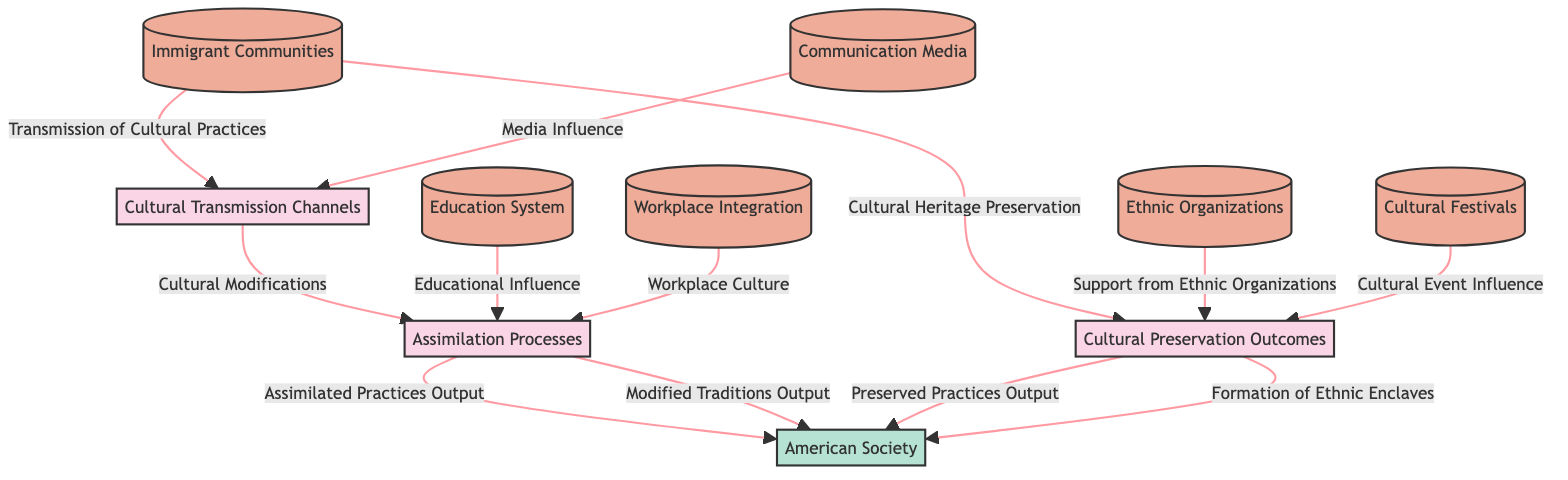What are the processes depicted in the diagram? The diagram lists three processes: Cultural Transmission Channels, Assimilation Processes, and Cultural Preservation Outcomes.
Answer: Cultural Transmission Channels, Assimilation Processes, Cultural Preservation Outcomes How many data stores are included in the diagram? There are six data stores identified in the diagram: Immigrant Communities, Communication Media, Education System, Workplace Integration, Ethnic Organizations, and Cultural Festivals.
Answer: Six What is the input for the Assimilation Processes? The inputs for Assimilation Processes are Cultural Influence in Society, Education System, and Workplace Integration.
Answer: Cultural Influence in Society, Education System, Workplace Integration What influences the Cultural Transmission Channels? Cultural Transmission Channels are influenced by Immigrant Communities and Communication Media.
Answer: Immigrant Communities, Communication Media Which process outputs Preserved Cultural Practices? The Cultural Preservation Outcomes process outputs Preserved Cultural Practices.
Answer: Cultural Preservation Outcomes What is the relationship between Cultural Transmission Channels and Assimilation Processes? Cultural Transmission Channels send cultural modifications to the Assimilation Processes, integrating cultural practices into American society.
Answer: Cultural Modifications Which entity interacts with the diagram and what is its role? The entity is the American Society, which represents the general population receiving and interacting with cultural practices from immigrant groups.
Answer: American Society What is the effect of Ethnic Organizations on cultural practices? Ethnic Organizations provide support for Cultural Preservation Outcomes, helping maintain immigrant cultural heritage.
Answer: Support from Ethnic Organizations How do Cultural Festivals contribute to the diagram? Cultural Festivals influence Cultural Preservation Outcomes by celebrating specific ethnic traditions, helping to maintain cultural identity.
Answer: Cultural Event Influence 